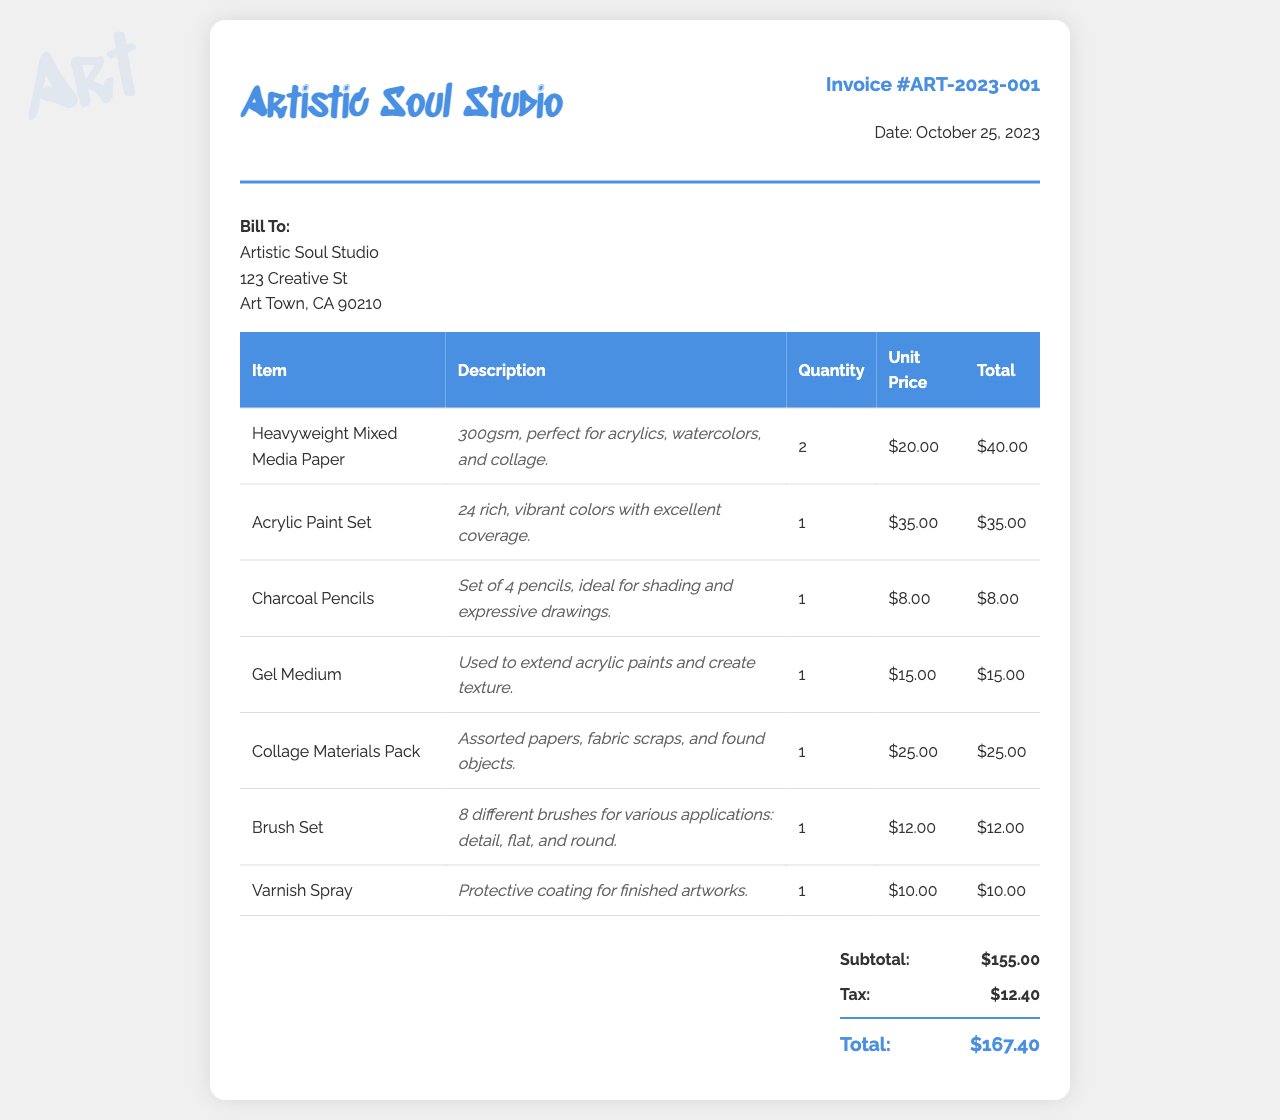What is the invoice number? The invoice number is listed prominently at the top of the document, which is ART-2023-001.
Answer: ART-2023-001 What is the date of the invoice? The date appears in the invoice details section, specified as October 25, 2023.
Answer: October 25, 2023 How many Heavyweight Mixed Media Papers were ordered? The quantity ordered for Heavyweight Mixed Media Paper is found in the order details, which states 2.
Answer: 2 What is the unit price of the Acrylic Paint Set? The unit price for the Acrylic Paint Set is indicated in the table, which is $35.00.
Answer: $35.00 What is the subtotal amount? The subtotal amount is calculated and displayed before tax, which shows $155.00.
Answer: $155.00 What is the grand total of the invoice? The grand total is highlighted at the bottom of the invoice, noted as $167.40.
Answer: $167.40 How many different brushes are included in the Brush Set? The Brush Set is described as containing 8 different brushes, mentioned in the description.
Answer: 8 What type of protective item is mentioned in this invoice? The invoice lists Varnish Spray, which serves as a protective coating for artworks.
Answer: Varnish Spray What is included in the Collage Materials Pack? The Collage Materials Pack is specified to include assorted papers, fabric scraps, and found objects in its description.
Answer: Assorted papers, fabric scraps, and found objects What tax amount is charged on the invoice? The tax amount is clearly stated in the total section, which is $12.40.
Answer: $12.40 